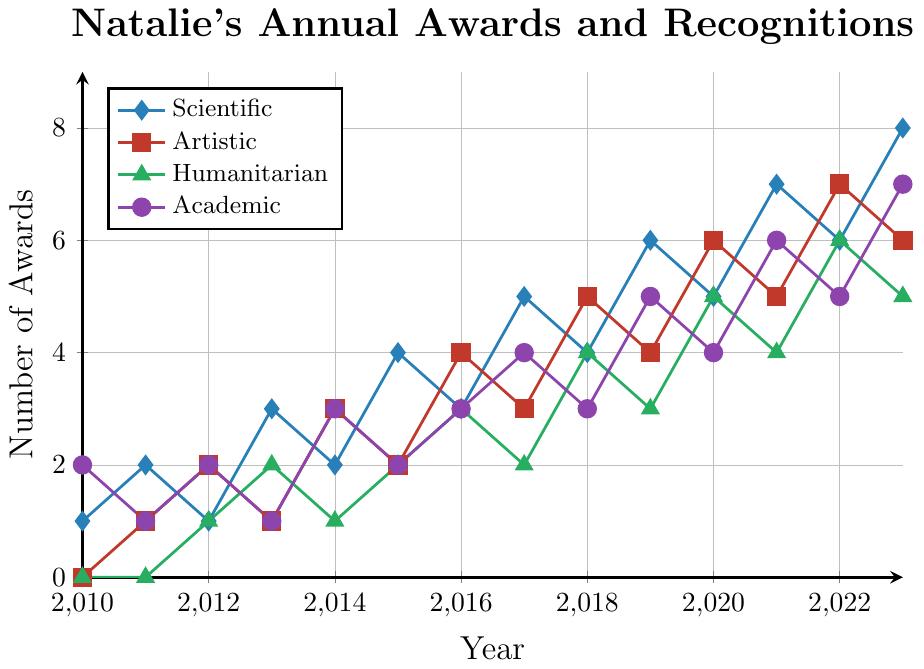What year did Natalie first receive a Humanitarian award? Look at the Humanitarian (green) line and find the first non-zero value, which is in 2012.
Answer: 2012 In which year did Natalie receive the highest number of Academic awards? Look at the Academic (purple) line and find the peak value, which is in 2023 with 7 awards.
Answer: 2023 How many total awards did Natalie receive in 2015? Sum the values of Scientific, Artistic, Humanitarian, and Academic awards for 2015: 4 (Scientific) + 2 (Artistic) + 2 (Humanitarian) + 2 (Academic) = 10.
Answer: 10 Which field had the most significant increase in awards from 2017 to 2018? Look at the change between 2017 and 2018 for each field. Scientific decreases by 1, Artistic increases by 2, Humanitarian increases by 2, and Academic remains the same. Both Artistic and Humanitarian have the most significant increase.
Answer: Artistic and Humanitarian What is the average number of Scientific awards received from 2010 to 2023? Sum all the Scientific awards from 2010 to 2023: (1+2+1+3+2+4+3+5+4+6+5+7+6+8 = 57). Divide by 14 years: 57 / 14 = 4.07.
Answer: 4.07 Which year had the lowest total number of awards combined across all fields? Calculate the total number of awards for each year and find the minimum value. The totals are: 2010 (3), 2011 (4), 2012 (6), 2013 (7), 2014 (9), 2015 (10), 2016 (13), 2017 (14), 2018 (16), 2019 (18), 2020 (20), 2021 (22), 2022 (24), 2023 (26). The lowest total is in 2010.
Answer: 2010 In which field did Natalie experience the most consistent growth in awards? Observe the lines for each field over the years. The Academic (purple) line shows a more steady increase, without drastic changes compared to others.
Answer: Academic Compare the number of Humanitarian awards received in 2016 and 2022. By how much did it increase? Humanitarian awards in 2016 were 3, and in 2022 they were 6. The increase is 6 - 3 = 3.
Answer: 3 How many times did Natalie receive more Artistic awards than Academic awards? Compare the values for Artistic and Academic awards each year. The years are 2014, 2016, 2018, 2020, and 2022, making it 5 times.
Answer: 5 Between 2010 and 2023, in how many years did Natalie receive the same number of Scientific and Humanitarian awards? Compare the values for Scientific and Humanitarian awards each year. The years are 2016 and 2023, making it 2 years.
Answer: 2 